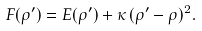<formula> <loc_0><loc_0><loc_500><loc_500>F ( \rho ^ { \prime } ) = E ( \rho ^ { \prime } ) + \kappa \, ( \rho ^ { \prime } - \rho ) ^ { 2 } .</formula> 